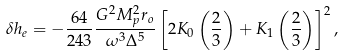<formula> <loc_0><loc_0><loc_500><loc_500>\delta h _ { e } = - \frac { 6 4 } { 2 4 3 } \frac { G ^ { 2 } M _ { p } ^ { 2 } r _ { o } } { \omega ^ { 3 } \Delta ^ { 5 } } \left [ 2 K _ { 0 } \left ( \frac { 2 } { 3 } \right ) + K _ { 1 } \left ( \frac { 2 } { 3 } \right ) \right ] ^ { 2 } ,</formula> 